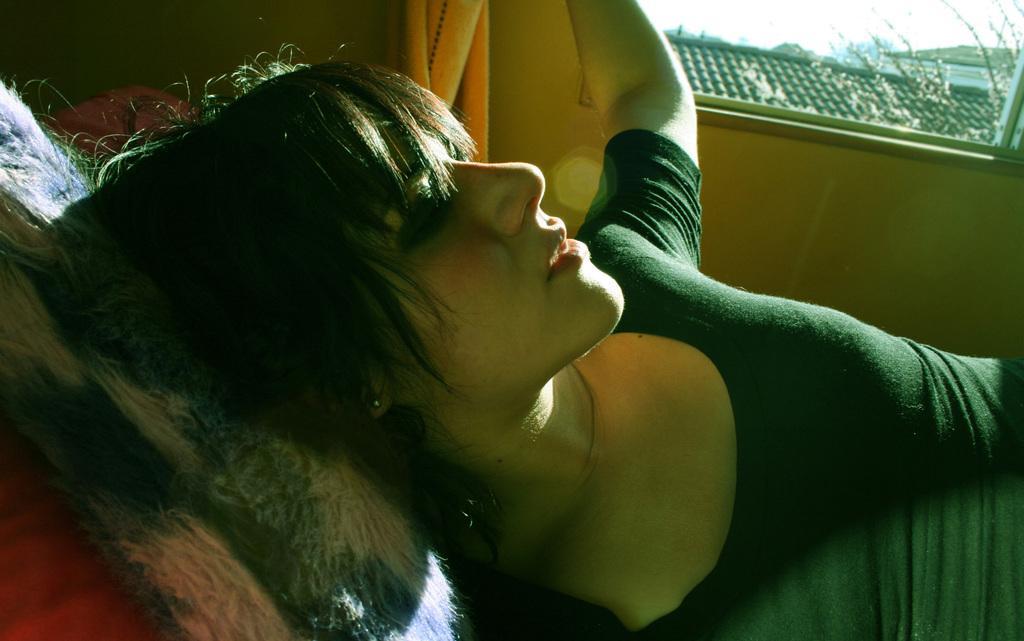Can you describe this image briefly? There is a lady lying and keeping the head on a pillow. In the back there is a wall and a window. Through the window we can see roof. 